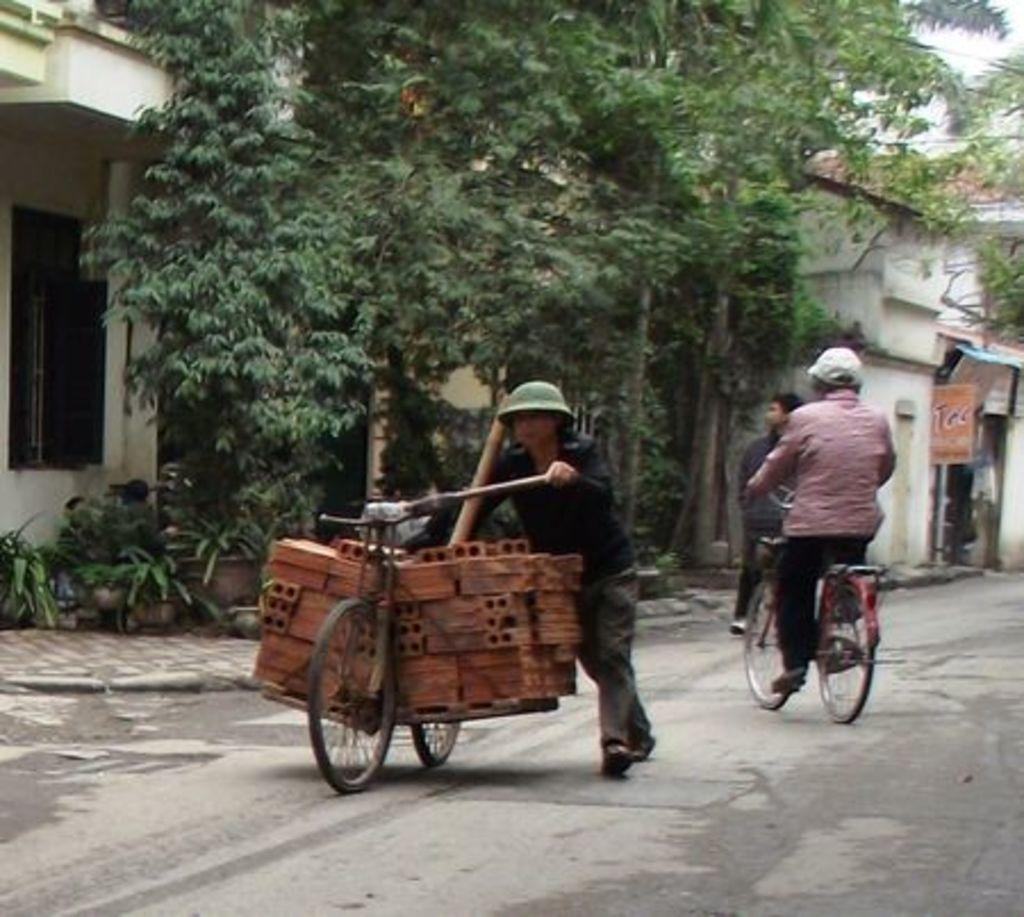Can you describe this image briefly? In this image the person is holding something and riding a bicycle. at the back side we can see a building,trees. 